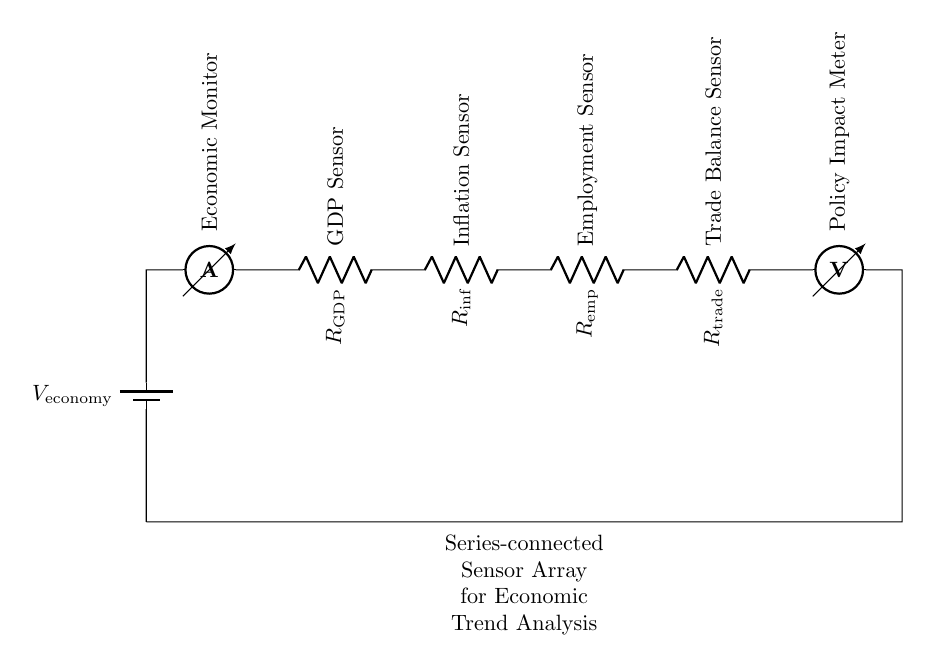What component provides the input voltage? The battery labeled as $V_\text{economy}$ serves as the input voltage for the circuit, supplying power to the series-connected sensors.
Answer: V economy What is the function of the ammeter in this circuit? The ammeter is labeled as the "Economic Monitor," which indicates it measures the current flowing through the circuit, reflecting the economic trends based on the sensor data.
Answer: Economic Monitor How many sensors are included in the array? The circuit includes four sensors: GDP Sensor, Inflation Sensor, Employment Sensor, and Trade Balance Sensor, all connected in series.
Answer: Four What is the role of the Policy Impact Meter? The Policy Impact Meter, represented as a voltmeter, measures the voltage drop across the series-connected sensors, reflecting the overall impact of various economic indicators on policy.
Answer: Measure policy impact What happens to the total resistance as more sensors are added in series? In a series circuit, the total resistance increases as each additional sensor (resistor) is connected because the resistances sum up.
Answer: Increases What is the relationship between current and resistance in this series circuit? According to Ohm's Law, the current is inversely proportional to the total resistance in the circuit when the voltage is constant, meaning that as resistance increases, current decreases.
Answer: Inversely proportional 